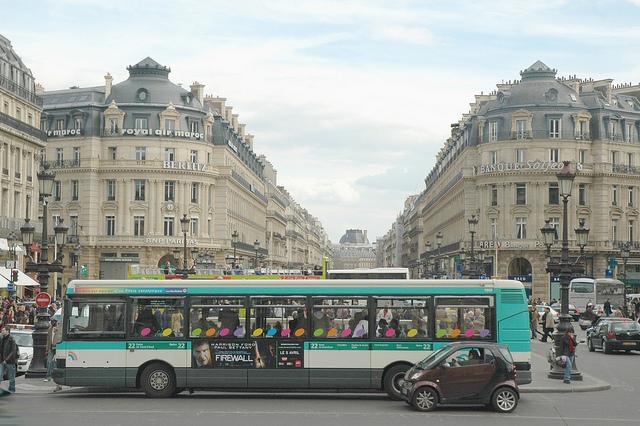Do the building look alike?
Concise answer only. Yes. Is this a city or countryside?
Answer briefly. City. What kind of car is next to the bus?
Short answer required. Smart car. 